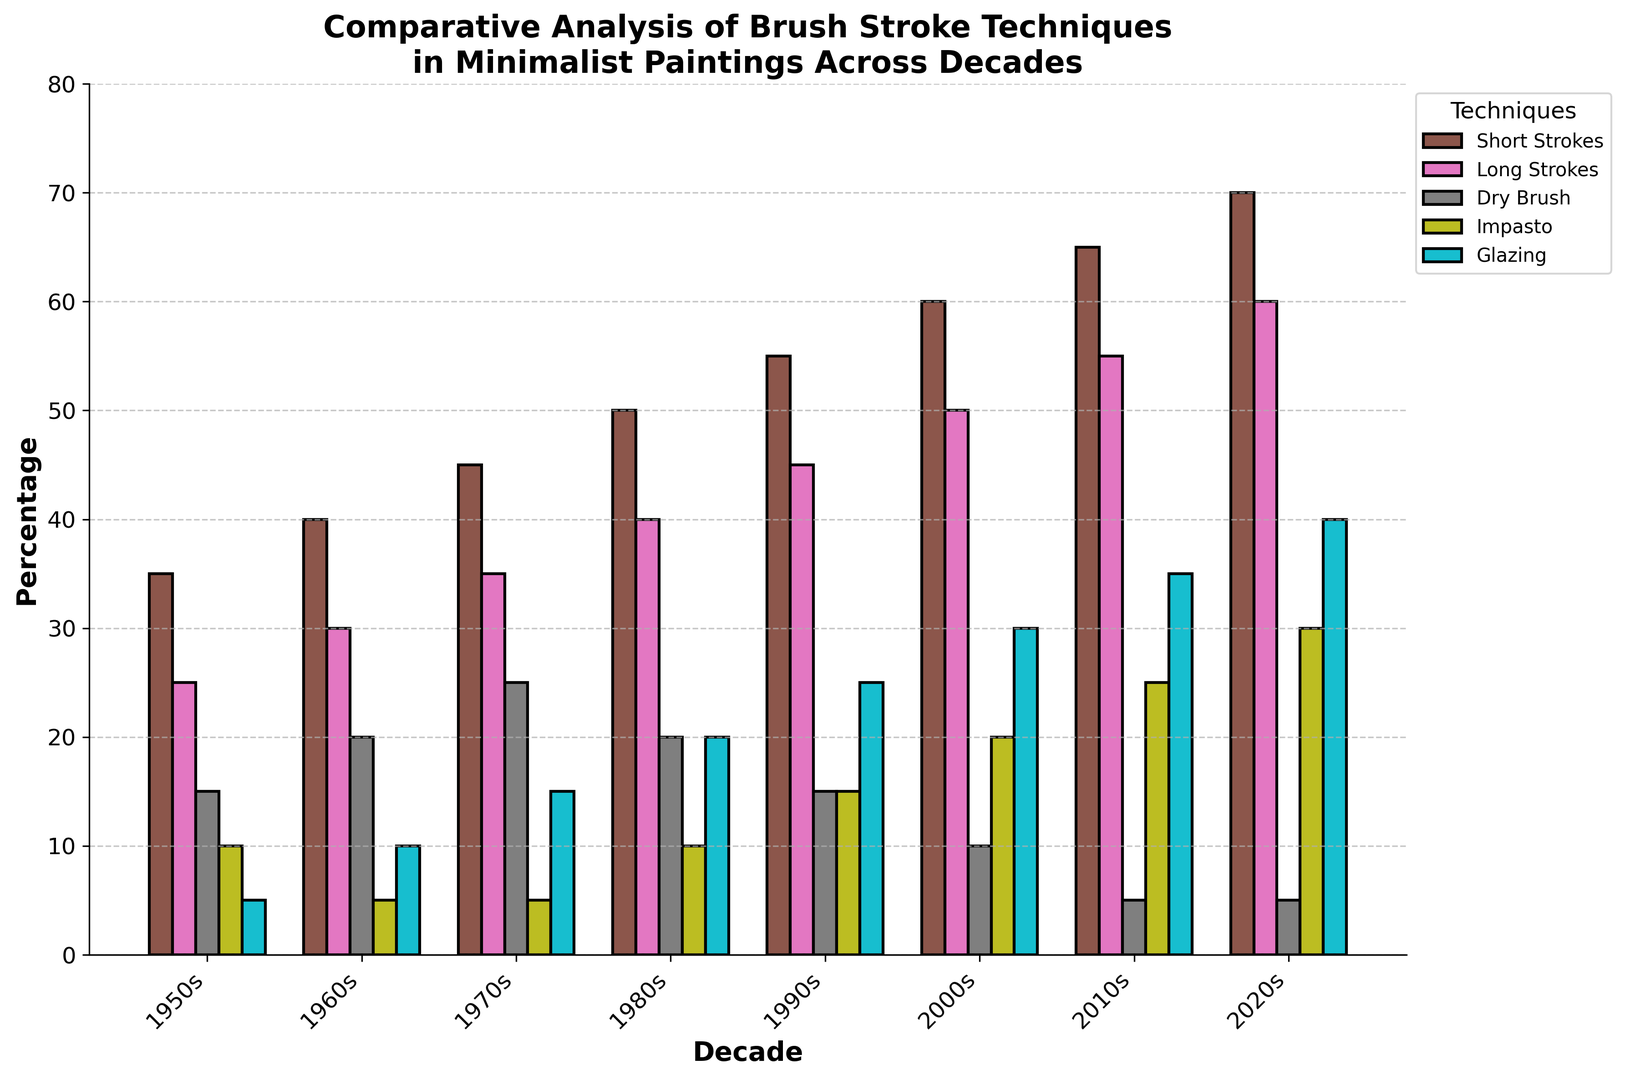Which technique had the highest percentage in the 2000s? Look at the 2000s column and compare the heights of the bars representing each technique. The bar for 'Long Strokes' reaches the highest percentage.
Answer: Long Strokes During which decade did 'Dry Brush' have its lowest percentage? Review the 'Dry Brush' bars across all decades to identify the shortest one. The shortest bar for 'Dry Brush' is in the 2010s.
Answer: 2010s Which technique shows a consistent increase in percentage from the 1950s to the 2020s? Examine the trend for each technique across decades. 'Short Strokes' consistently increases from the 1950s to the 2020s.
Answer: Short Strokes How does the percentage of 'Impasto' in the 1980s compare to its percentage in the 1990s? Check the heights of the 'Impasto' bars for the 1980s and 1990s. The bar for the 1990s is higher, indicating an increase.
Answer: It increased What is the combined percentage of 'Glazing' in the 1990s and 2020s? Add the percentages of 'Glazing' for the 1990s and 2020s: 25% + 40%.
Answer: 65% By how much did the use of 'Short Strokes' increase from the 1950s to the 2020s? Subtract the percentage in the 1950s from the percentage in the 2020s for 'Short Strokes': 70% - 35%.
Answer: 35% Which decade shows the highest variation in the usage of different techniques? Compare the range (difference between the highest and lowest values) of percentages for each decade. The widest range appears in the 2020s.
Answer: 2020s In which decade did 'Long Strokes' become more prevalent than 'Short Strokes'? Compare the 'Long Strokes' and 'Short Strokes' bars for each decade. 'Long Strokes' surpass 'Short Strokes' starting in the 2010s.
Answer: 2010s What is the trend in the use of 'Glazing' from the 1950s to the 2020s? Observe the direction of 'Glazing' bars over the decades. The bars progressively increase, showing an upward trend.
Answer: Upward trend Which technique exhibited the most drastic percentage change between two consecutive decades? Identify and compare changes between consecutive decades for each technique. The jump between decades is most drastic for 'Impasto' from the 2010s to the 2020s (25% to 30%).
Answer: Impasto 